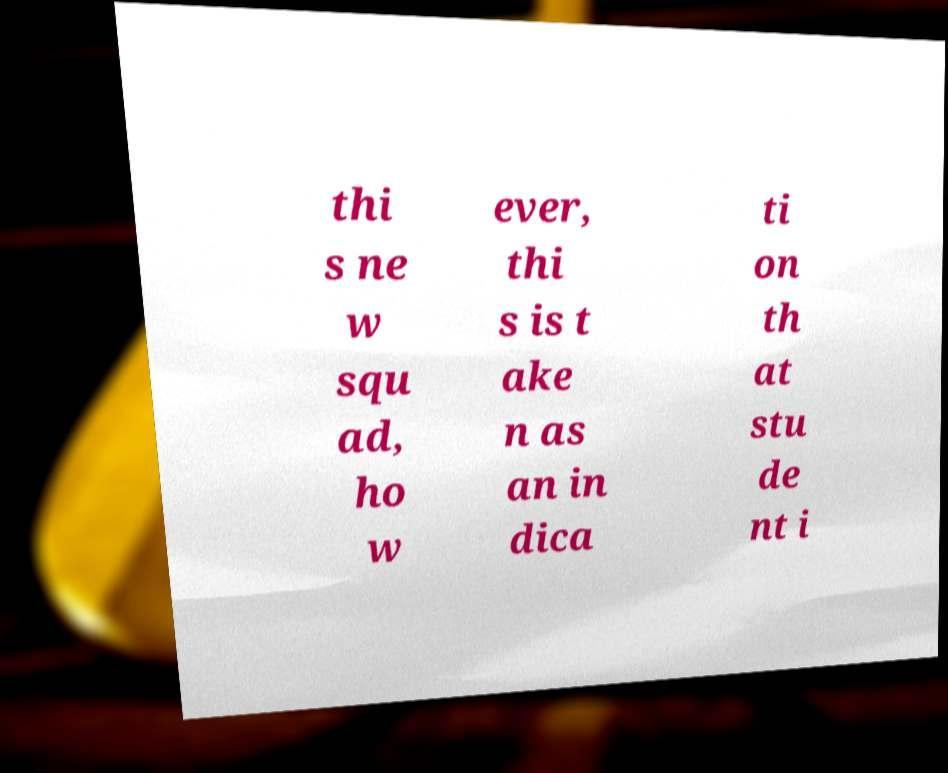Can you read and provide the text displayed in the image?This photo seems to have some interesting text. Can you extract and type it out for me? thi s ne w squ ad, ho w ever, thi s is t ake n as an in dica ti on th at stu de nt i 